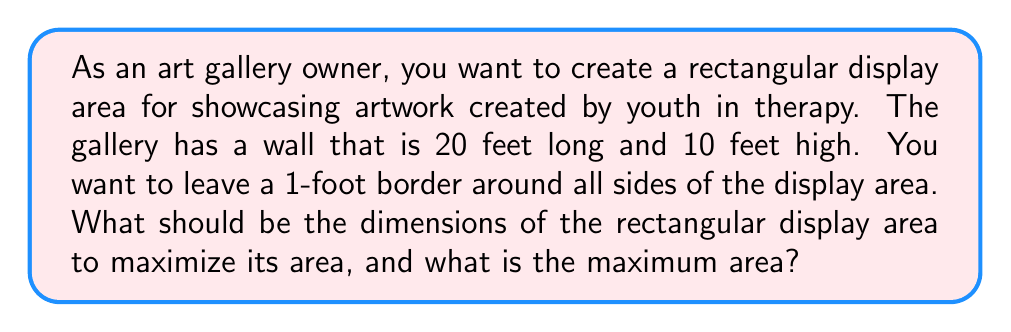Give your solution to this math problem. Let's approach this step-by-step:

1) Let the width of the display area be $w$ and the height be $h$.

2) Given the constraints:
   $w + 2 = 20$ (width plus 2 feet for borders)
   $h + 2 = 10$ (height plus 2 feet for borders)

3) Solving these:
   $w = 18$ and $h = 8$

4) The area of the display is given by $A = wh$

5) Substituting:
   $A = 18h$

6) We know $h$ can be at most 8, so the maximum area will occur when $h = 8$

7) Therefore, the maximum area is:
   $A_{max} = 18 * 8 = 144$ square feet

8) The optimal dimensions are 18 feet wide by 8 feet high.

[asy]
size(200,100);
draw((0,0)--(20,0)--(20,10)--(0,10)--cycle);
draw((1,1)--(19,1)--(19,9)--(1,9)--cycle);
label("20'",(10,0),S);
label("10'",(0,5),W);
label("18'",(10,1),N);
label("8'",(1,5),E);
[/asy]
Answer: The optimal dimensions for the display area are 18 feet wide by 8 feet high, with a maximum area of 144 square feet. 